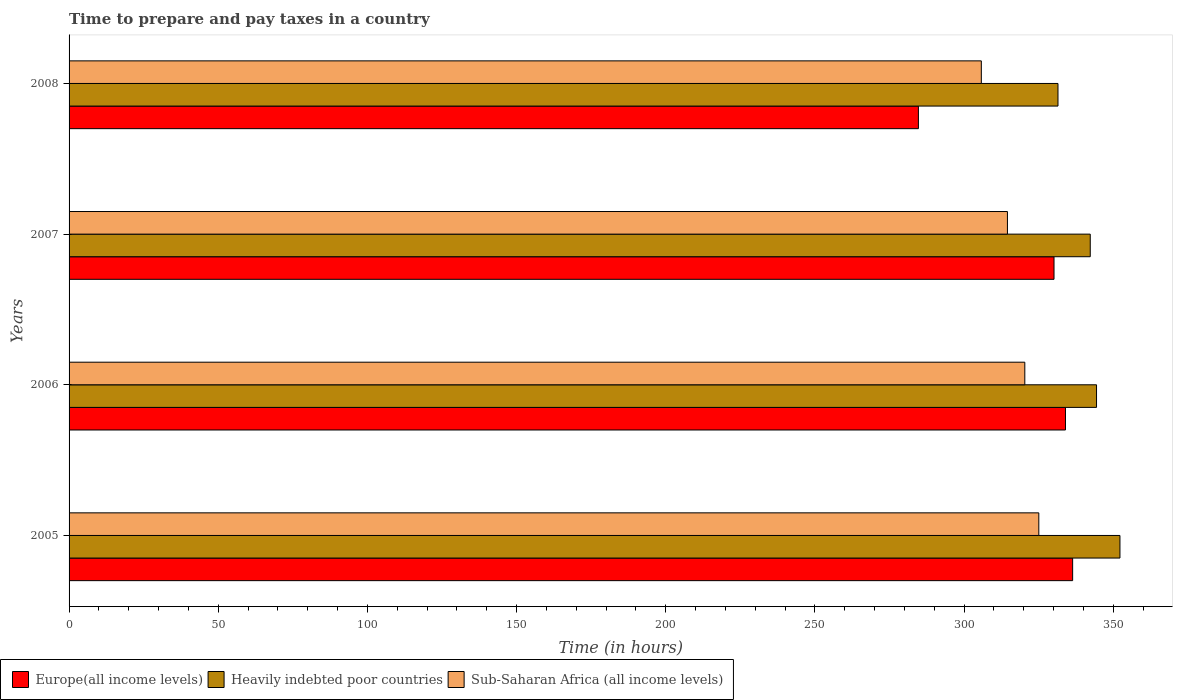How many different coloured bars are there?
Give a very brief answer. 3. How many groups of bars are there?
Your response must be concise. 4. Are the number of bars on each tick of the Y-axis equal?
Provide a succinct answer. Yes. How many bars are there on the 1st tick from the top?
Your answer should be very brief. 3. How many bars are there on the 2nd tick from the bottom?
Provide a short and direct response. 3. What is the number of hours required to prepare and pay taxes in Europe(all income levels) in 2008?
Give a very brief answer. 284.69. Across all years, what is the maximum number of hours required to prepare and pay taxes in Europe(all income levels)?
Your response must be concise. 336.38. Across all years, what is the minimum number of hours required to prepare and pay taxes in Sub-Saharan Africa (all income levels)?
Offer a very short reply. 305.78. In which year was the number of hours required to prepare and pay taxes in Europe(all income levels) maximum?
Keep it short and to the point. 2005. What is the total number of hours required to prepare and pay taxes in Europe(all income levels) in the graph?
Your answer should be very brief. 1285.21. What is the difference between the number of hours required to prepare and pay taxes in Europe(all income levels) in 2005 and that in 2007?
Make the answer very short. 6.24. What is the difference between the number of hours required to prepare and pay taxes in Europe(all income levels) in 2006 and the number of hours required to prepare and pay taxes in Heavily indebted poor countries in 2007?
Offer a very short reply. -8.3. What is the average number of hours required to prepare and pay taxes in Europe(all income levels) per year?
Keep it short and to the point. 321.3. In the year 2007, what is the difference between the number of hours required to prepare and pay taxes in Sub-Saharan Africa (all income levels) and number of hours required to prepare and pay taxes in Europe(all income levels)?
Your answer should be very brief. -15.61. In how many years, is the number of hours required to prepare and pay taxes in Sub-Saharan Africa (all income levels) greater than 40 hours?
Make the answer very short. 4. What is the ratio of the number of hours required to prepare and pay taxes in Europe(all income levels) in 2007 to that in 2008?
Provide a short and direct response. 1.16. Is the number of hours required to prepare and pay taxes in Heavily indebted poor countries in 2005 less than that in 2008?
Offer a very short reply. No. Is the difference between the number of hours required to prepare and pay taxes in Sub-Saharan Africa (all income levels) in 2006 and 2007 greater than the difference between the number of hours required to prepare and pay taxes in Europe(all income levels) in 2006 and 2007?
Make the answer very short. Yes. What is the difference between the highest and the second highest number of hours required to prepare and pay taxes in Europe(all income levels)?
Provide a short and direct response. 2.39. What is the difference between the highest and the lowest number of hours required to prepare and pay taxes in Sub-Saharan Africa (all income levels)?
Offer a terse response. 19.27. What does the 3rd bar from the top in 2005 represents?
Keep it short and to the point. Europe(all income levels). What does the 2nd bar from the bottom in 2007 represents?
Ensure brevity in your answer.  Heavily indebted poor countries. Are all the bars in the graph horizontal?
Provide a short and direct response. Yes. How many years are there in the graph?
Keep it short and to the point. 4. What is the difference between two consecutive major ticks on the X-axis?
Ensure brevity in your answer.  50. Does the graph contain grids?
Ensure brevity in your answer.  No. How many legend labels are there?
Provide a succinct answer. 3. How are the legend labels stacked?
Offer a terse response. Horizontal. What is the title of the graph?
Provide a succinct answer. Time to prepare and pay taxes in a country. What is the label or title of the X-axis?
Provide a succinct answer. Time (in hours). What is the label or title of the Y-axis?
Provide a succinct answer. Years. What is the Time (in hours) of Europe(all income levels) in 2005?
Your answer should be very brief. 336.38. What is the Time (in hours) of Heavily indebted poor countries in 2005?
Your answer should be very brief. 352.24. What is the Time (in hours) in Sub-Saharan Africa (all income levels) in 2005?
Your answer should be very brief. 325.05. What is the Time (in hours) in Europe(all income levels) in 2006?
Your answer should be compact. 333.99. What is the Time (in hours) of Heavily indebted poor countries in 2006?
Offer a terse response. 344.39. What is the Time (in hours) in Sub-Saharan Africa (all income levels) in 2006?
Your answer should be very brief. 320.36. What is the Time (in hours) in Europe(all income levels) in 2007?
Keep it short and to the point. 330.14. What is the Time (in hours) of Heavily indebted poor countries in 2007?
Make the answer very short. 342.29. What is the Time (in hours) in Sub-Saharan Africa (all income levels) in 2007?
Make the answer very short. 314.53. What is the Time (in hours) in Europe(all income levels) in 2008?
Give a very brief answer. 284.69. What is the Time (in hours) of Heavily indebted poor countries in 2008?
Offer a terse response. 331.47. What is the Time (in hours) of Sub-Saharan Africa (all income levels) in 2008?
Offer a very short reply. 305.78. Across all years, what is the maximum Time (in hours) in Europe(all income levels)?
Your answer should be very brief. 336.38. Across all years, what is the maximum Time (in hours) in Heavily indebted poor countries?
Your answer should be very brief. 352.24. Across all years, what is the maximum Time (in hours) of Sub-Saharan Africa (all income levels)?
Provide a succinct answer. 325.05. Across all years, what is the minimum Time (in hours) in Europe(all income levels)?
Your answer should be very brief. 284.69. Across all years, what is the minimum Time (in hours) of Heavily indebted poor countries?
Keep it short and to the point. 331.47. Across all years, what is the minimum Time (in hours) in Sub-Saharan Africa (all income levels)?
Your answer should be very brief. 305.78. What is the total Time (in hours) of Europe(all income levels) in the graph?
Provide a short and direct response. 1285.21. What is the total Time (in hours) of Heavily indebted poor countries in the graph?
Your answer should be compact. 1370.4. What is the total Time (in hours) in Sub-Saharan Africa (all income levels) in the graph?
Your response must be concise. 1265.71. What is the difference between the Time (in hours) in Europe(all income levels) in 2005 and that in 2006?
Provide a short and direct response. 2.39. What is the difference between the Time (in hours) of Heavily indebted poor countries in 2005 and that in 2006?
Your answer should be compact. 7.85. What is the difference between the Time (in hours) in Sub-Saharan Africa (all income levels) in 2005 and that in 2006?
Keep it short and to the point. 4.69. What is the difference between the Time (in hours) of Europe(all income levels) in 2005 and that in 2007?
Ensure brevity in your answer.  6.24. What is the difference between the Time (in hours) in Heavily indebted poor countries in 2005 and that in 2007?
Ensure brevity in your answer.  9.95. What is the difference between the Time (in hours) in Sub-Saharan Africa (all income levels) in 2005 and that in 2007?
Your answer should be compact. 10.51. What is the difference between the Time (in hours) in Europe(all income levels) in 2005 and that in 2008?
Offer a terse response. 51.69. What is the difference between the Time (in hours) of Heavily indebted poor countries in 2005 and that in 2008?
Your response must be concise. 20.77. What is the difference between the Time (in hours) of Sub-Saharan Africa (all income levels) in 2005 and that in 2008?
Your response must be concise. 19.27. What is the difference between the Time (in hours) in Europe(all income levels) in 2006 and that in 2007?
Provide a short and direct response. 3.84. What is the difference between the Time (in hours) in Heavily indebted poor countries in 2006 and that in 2007?
Your answer should be very brief. 2.11. What is the difference between the Time (in hours) in Sub-Saharan Africa (all income levels) in 2006 and that in 2007?
Make the answer very short. 5.82. What is the difference between the Time (in hours) of Europe(all income levels) in 2006 and that in 2008?
Give a very brief answer. 49.3. What is the difference between the Time (in hours) of Heavily indebted poor countries in 2006 and that in 2008?
Your answer should be compact. 12.92. What is the difference between the Time (in hours) of Sub-Saharan Africa (all income levels) in 2006 and that in 2008?
Provide a short and direct response. 14.58. What is the difference between the Time (in hours) of Europe(all income levels) in 2007 and that in 2008?
Give a very brief answer. 45.46. What is the difference between the Time (in hours) in Heavily indebted poor countries in 2007 and that in 2008?
Provide a short and direct response. 10.82. What is the difference between the Time (in hours) in Sub-Saharan Africa (all income levels) in 2007 and that in 2008?
Ensure brevity in your answer.  8.76. What is the difference between the Time (in hours) in Europe(all income levels) in 2005 and the Time (in hours) in Heavily indebted poor countries in 2006?
Your response must be concise. -8.01. What is the difference between the Time (in hours) in Europe(all income levels) in 2005 and the Time (in hours) in Sub-Saharan Africa (all income levels) in 2006?
Provide a short and direct response. 16.03. What is the difference between the Time (in hours) in Heavily indebted poor countries in 2005 and the Time (in hours) in Sub-Saharan Africa (all income levels) in 2006?
Your answer should be compact. 31.89. What is the difference between the Time (in hours) of Europe(all income levels) in 2005 and the Time (in hours) of Heavily indebted poor countries in 2007?
Offer a very short reply. -5.91. What is the difference between the Time (in hours) of Europe(all income levels) in 2005 and the Time (in hours) of Sub-Saharan Africa (all income levels) in 2007?
Keep it short and to the point. 21.85. What is the difference between the Time (in hours) in Heavily indebted poor countries in 2005 and the Time (in hours) in Sub-Saharan Africa (all income levels) in 2007?
Your answer should be very brief. 37.71. What is the difference between the Time (in hours) of Europe(all income levels) in 2005 and the Time (in hours) of Heavily indebted poor countries in 2008?
Provide a short and direct response. 4.91. What is the difference between the Time (in hours) of Europe(all income levels) in 2005 and the Time (in hours) of Sub-Saharan Africa (all income levels) in 2008?
Provide a succinct answer. 30.61. What is the difference between the Time (in hours) in Heavily indebted poor countries in 2005 and the Time (in hours) in Sub-Saharan Africa (all income levels) in 2008?
Offer a terse response. 46.47. What is the difference between the Time (in hours) of Europe(all income levels) in 2006 and the Time (in hours) of Heavily indebted poor countries in 2007?
Your answer should be very brief. -8.3. What is the difference between the Time (in hours) in Europe(all income levels) in 2006 and the Time (in hours) in Sub-Saharan Africa (all income levels) in 2007?
Your response must be concise. 19.46. What is the difference between the Time (in hours) of Heavily indebted poor countries in 2006 and the Time (in hours) of Sub-Saharan Africa (all income levels) in 2007?
Make the answer very short. 29.86. What is the difference between the Time (in hours) in Europe(all income levels) in 2006 and the Time (in hours) in Heavily indebted poor countries in 2008?
Your answer should be very brief. 2.52. What is the difference between the Time (in hours) of Europe(all income levels) in 2006 and the Time (in hours) of Sub-Saharan Africa (all income levels) in 2008?
Your answer should be very brief. 28.21. What is the difference between the Time (in hours) in Heavily indebted poor countries in 2006 and the Time (in hours) in Sub-Saharan Africa (all income levels) in 2008?
Offer a terse response. 38.62. What is the difference between the Time (in hours) in Europe(all income levels) in 2007 and the Time (in hours) in Heavily indebted poor countries in 2008?
Your answer should be very brief. -1.33. What is the difference between the Time (in hours) of Europe(all income levels) in 2007 and the Time (in hours) of Sub-Saharan Africa (all income levels) in 2008?
Provide a short and direct response. 24.37. What is the difference between the Time (in hours) of Heavily indebted poor countries in 2007 and the Time (in hours) of Sub-Saharan Africa (all income levels) in 2008?
Your answer should be compact. 36.51. What is the average Time (in hours) in Europe(all income levels) per year?
Keep it short and to the point. 321.3. What is the average Time (in hours) of Heavily indebted poor countries per year?
Your response must be concise. 342.6. What is the average Time (in hours) in Sub-Saharan Africa (all income levels) per year?
Offer a very short reply. 316.43. In the year 2005, what is the difference between the Time (in hours) of Europe(all income levels) and Time (in hours) of Heavily indebted poor countries?
Make the answer very short. -15.86. In the year 2005, what is the difference between the Time (in hours) of Europe(all income levels) and Time (in hours) of Sub-Saharan Africa (all income levels)?
Your response must be concise. 11.34. In the year 2005, what is the difference between the Time (in hours) of Heavily indebted poor countries and Time (in hours) of Sub-Saharan Africa (all income levels)?
Give a very brief answer. 27.2. In the year 2006, what is the difference between the Time (in hours) of Europe(all income levels) and Time (in hours) of Heavily indebted poor countries?
Your response must be concise. -10.41. In the year 2006, what is the difference between the Time (in hours) of Europe(all income levels) and Time (in hours) of Sub-Saharan Africa (all income levels)?
Give a very brief answer. 13.63. In the year 2006, what is the difference between the Time (in hours) in Heavily indebted poor countries and Time (in hours) in Sub-Saharan Africa (all income levels)?
Keep it short and to the point. 24.04. In the year 2007, what is the difference between the Time (in hours) of Europe(all income levels) and Time (in hours) of Heavily indebted poor countries?
Provide a short and direct response. -12.14. In the year 2007, what is the difference between the Time (in hours) of Europe(all income levels) and Time (in hours) of Sub-Saharan Africa (all income levels)?
Provide a short and direct response. 15.61. In the year 2007, what is the difference between the Time (in hours) of Heavily indebted poor countries and Time (in hours) of Sub-Saharan Africa (all income levels)?
Your response must be concise. 27.76. In the year 2008, what is the difference between the Time (in hours) of Europe(all income levels) and Time (in hours) of Heavily indebted poor countries?
Give a very brief answer. -46.78. In the year 2008, what is the difference between the Time (in hours) in Europe(all income levels) and Time (in hours) in Sub-Saharan Africa (all income levels)?
Your answer should be compact. -21.09. In the year 2008, what is the difference between the Time (in hours) of Heavily indebted poor countries and Time (in hours) of Sub-Saharan Africa (all income levels)?
Give a very brief answer. 25.7. What is the ratio of the Time (in hours) of Heavily indebted poor countries in 2005 to that in 2006?
Provide a succinct answer. 1.02. What is the ratio of the Time (in hours) of Sub-Saharan Africa (all income levels) in 2005 to that in 2006?
Ensure brevity in your answer.  1.01. What is the ratio of the Time (in hours) of Europe(all income levels) in 2005 to that in 2007?
Provide a short and direct response. 1.02. What is the ratio of the Time (in hours) in Heavily indebted poor countries in 2005 to that in 2007?
Give a very brief answer. 1.03. What is the ratio of the Time (in hours) in Sub-Saharan Africa (all income levels) in 2005 to that in 2007?
Offer a very short reply. 1.03. What is the ratio of the Time (in hours) of Europe(all income levels) in 2005 to that in 2008?
Your answer should be very brief. 1.18. What is the ratio of the Time (in hours) in Heavily indebted poor countries in 2005 to that in 2008?
Provide a short and direct response. 1.06. What is the ratio of the Time (in hours) of Sub-Saharan Africa (all income levels) in 2005 to that in 2008?
Make the answer very short. 1.06. What is the ratio of the Time (in hours) of Europe(all income levels) in 2006 to that in 2007?
Provide a succinct answer. 1.01. What is the ratio of the Time (in hours) of Heavily indebted poor countries in 2006 to that in 2007?
Give a very brief answer. 1.01. What is the ratio of the Time (in hours) of Sub-Saharan Africa (all income levels) in 2006 to that in 2007?
Provide a succinct answer. 1.02. What is the ratio of the Time (in hours) of Europe(all income levels) in 2006 to that in 2008?
Your answer should be very brief. 1.17. What is the ratio of the Time (in hours) in Heavily indebted poor countries in 2006 to that in 2008?
Keep it short and to the point. 1.04. What is the ratio of the Time (in hours) in Sub-Saharan Africa (all income levels) in 2006 to that in 2008?
Offer a terse response. 1.05. What is the ratio of the Time (in hours) in Europe(all income levels) in 2007 to that in 2008?
Keep it short and to the point. 1.16. What is the ratio of the Time (in hours) in Heavily indebted poor countries in 2007 to that in 2008?
Your answer should be compact. 1.03. What is the ratio of the Time (in hours) in Sub-Saharan Africa (all income levels) in 2007 to that in 2008?
Offer a very short reply. 1.03. What is the difference between the highest and the second highest Time (in hours) of Europe(all income levels)?
Keep it short and to the point. 2.39. What is the difference between the highest and the second highest Time (in hours) in Heavily indebted poor countries?
Provide a succinct answer. 7.85. What is the difference between the highest and the second highest Time (in hours) in Sub-Saharan Africa (all income levels)?
Ensure brevity in your answer.  4.69. What is the difference between the highest and the lowest Time (in hours) in Europe(all income levels)?
Make the answer very short. 51.69. What is the difference between the highest and the lowest Time (in hours) in Heavily indebted poor countries?
Offer a very short reply. 20.77. What is the difference between the highest and the lowest Time (in hours) in Sub-Saharan Africa (all income levels)?
Your answer should be very brief. 19.27. 